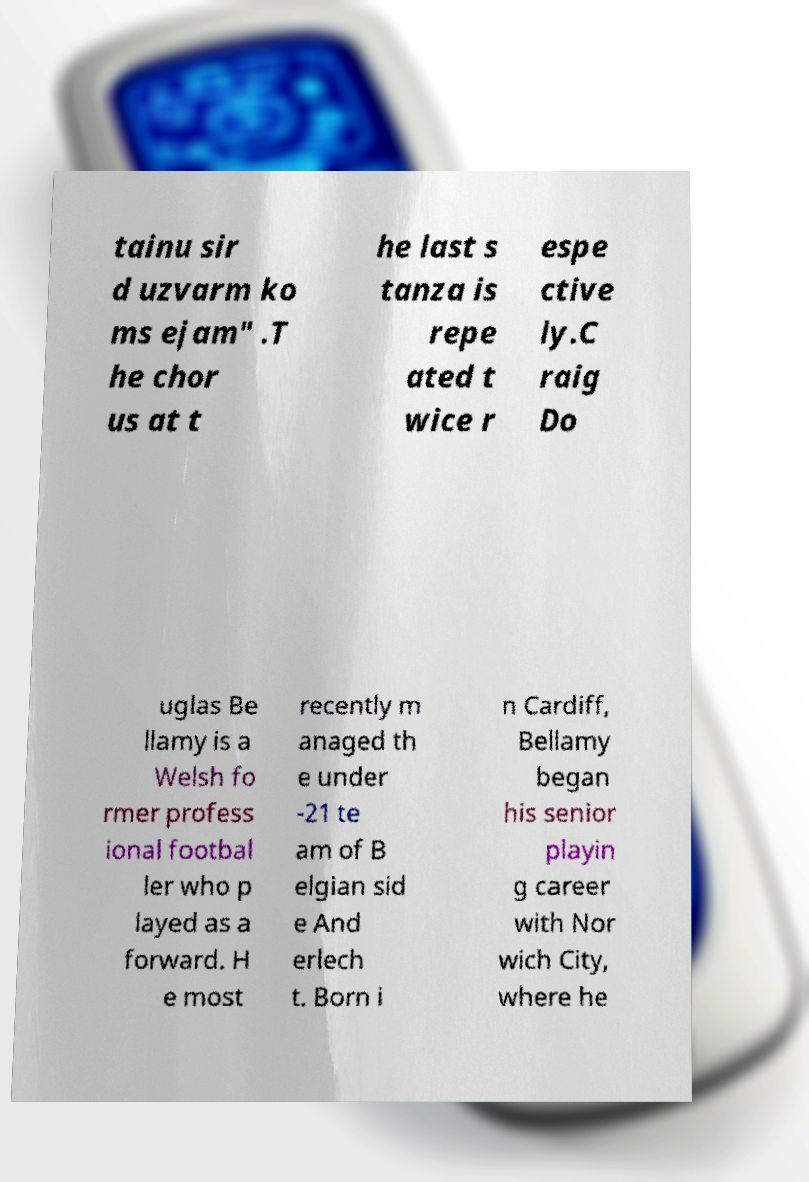Can you read and provide the text displayed in the image?This photo seems to have some interesting text. Can you extract and type it out for me? tainu sir d uzvarm ko ms ejam" .T he chor us at t he last s tanza is repe ated t wice r espe ctive ly.C raig Do uglas Be llamy is a Welsh fo rmer profess ional footbal ler who p layed as a forward. H e most recently m anaged th e under -21 te am of B elgian sid e And erlech t. Born i n Cardiff, Bellamy began his senior playin g career with Nor wich City, where he 